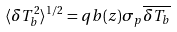Convert formula to latex. <formula><loc_0><loc_0><loc_500><loc_500>\langle \delta T _ { b } ^ { 2 } \rangle ^ { 1 / 2 } = q b ( z ) \sigma _ { p } \overline { \delta T _ { b } }</formula> 